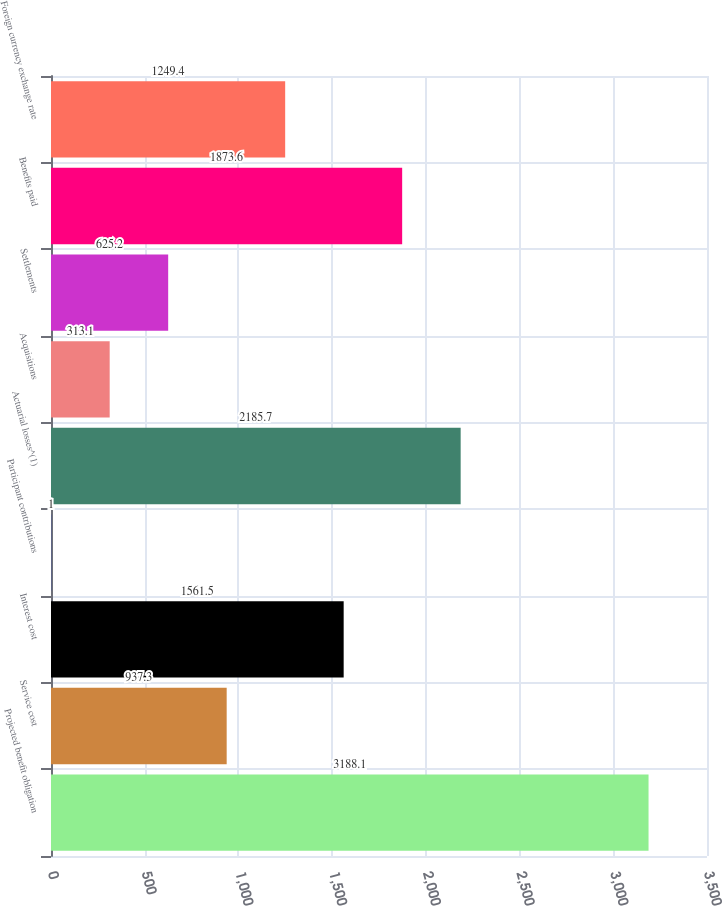Convert chart. <chart><loc_0><loc_0><loc_500><loc_500><bar_chart><fcel>Projected benefit obligation<fcel>Service cost<fcel>Interest cost<fcel>Participant contributions<fcel>Actuarial losses^(1)<fcel>Acquisitions<fcel>Settlements<fcel>Benefits paid<fcel>Foreign currency exchange rate<nl><fcel>3188.1<fcel>937.3<fcel>1561.5<fcel>1<fcel>2185.7<fcel>313.1<fcel>625.2<fcel>1873.6<fcel>1249.4<nl></chart> 